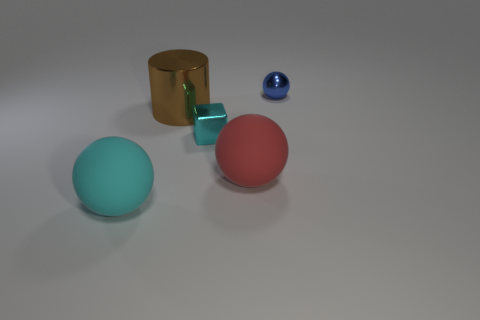How many objects are large cyan metal cylinders or spheres that are behind the big brown thing?
Offer a very short reply. 1. What number of blue spheres are in front of the tiny metal thing in front of the ball that is behind the red object?
Your answer should be very brief. 0. What number of cyan shiny spheres are there?
Ensure brevity in your answer.  0. There is a metallic object behind the brown shiny cylinder; is it the same size as the big metallic object?
Keep it short and to the point. No. What number of rubber objects are yellow cubes or cyan cubes?
Your answer should be very brief. 0. There is a rubber sphere that is behind the large cyan thing; how many brown cylinders are in front of it?
Ensure brevity in your answer.  0. What shape is the thing that is behind the big cyan object and on the left side of the small cube?
Give a very brief answer. Cylinder. There is a cyan thing behind the large rubber object right of the big rubber ball that is on the left side of the red matte ball; what is it made of?
Provide a succinct answer. Metal. What is the material of the big red thing?
Make the answer very short. Rubber. Is the material of the blue sphere the same as the big sphere to the left of the metallic block?
Provide a short and direct response. No. 